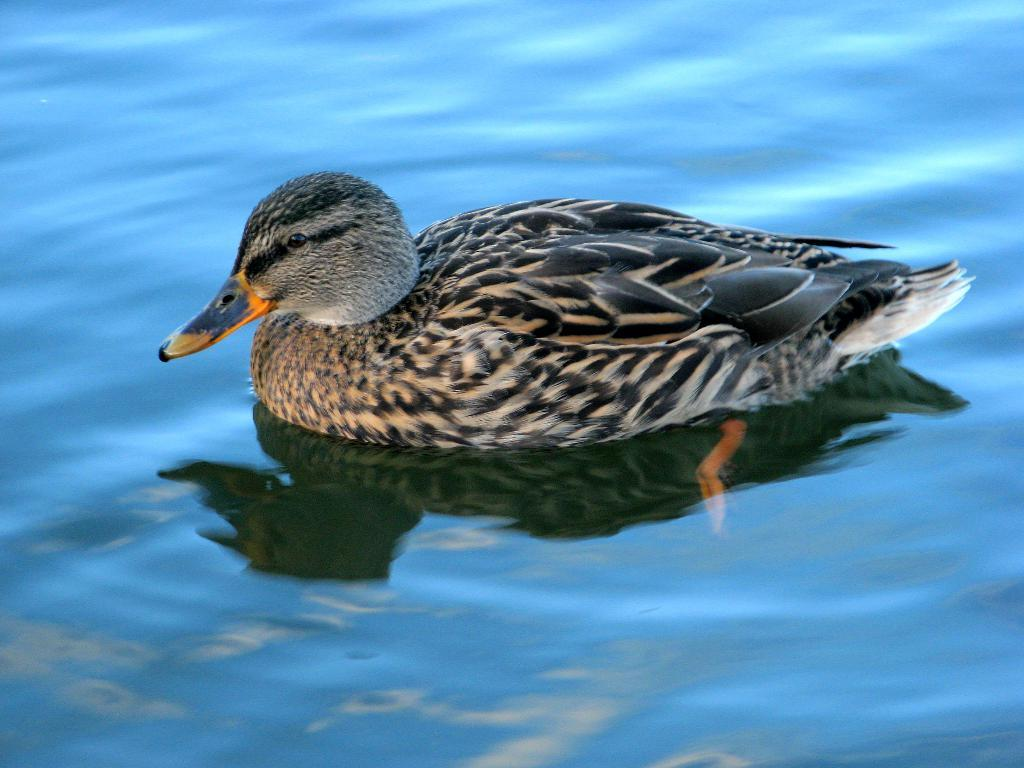What is present in the image? There is water and a duck in the image. Can you describe the duck in the image? The duck is in the water. What type of environment is depicted in the image? The image shows a watery environment. What type of fiction is being read in the office setting in the image? There is no office setting or fiction present in the image; it only features water and a duck. 